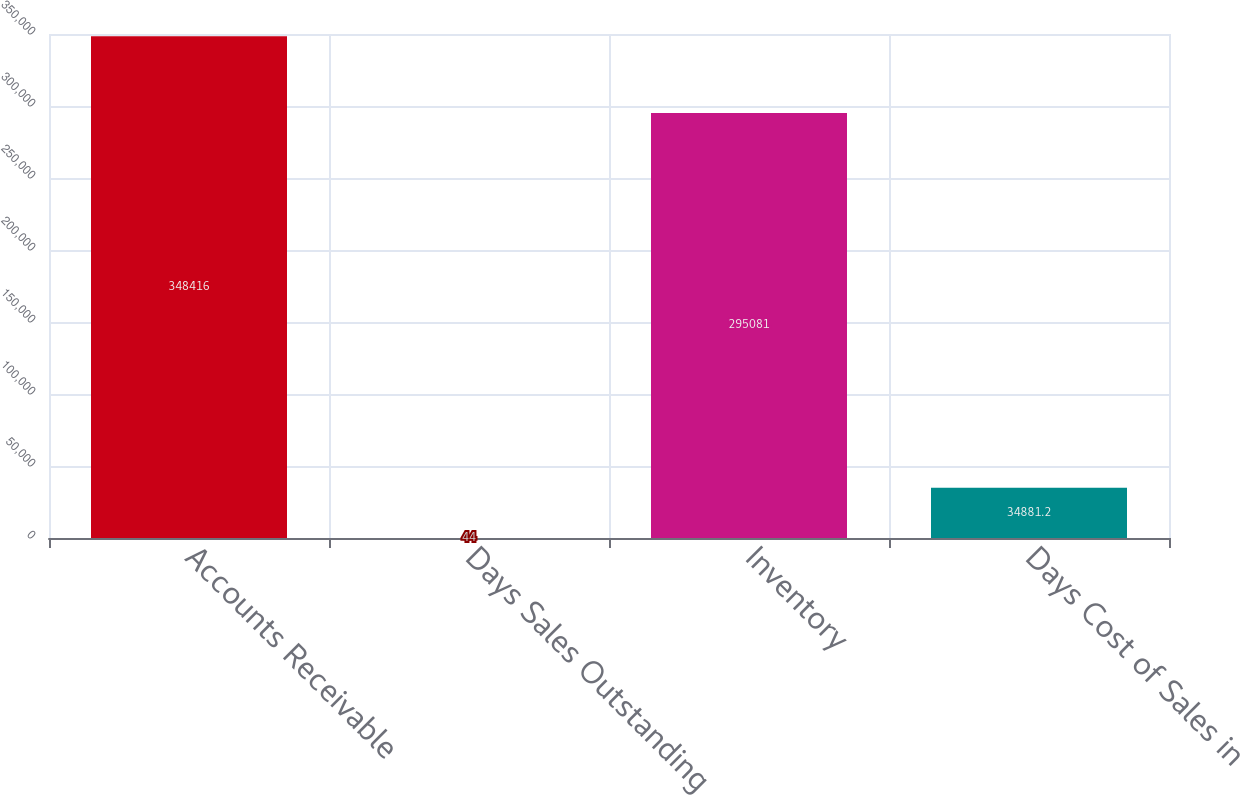Convert chart to OTSL. <chart><loc_0><loc_0><loc_500><loc_500><bar_chart><fcel>Accounts Receivable<fcel>Days Sales Outstanding<fcel>Inventory<fcel>Days Cost of Sales in<nl><fcel>348416<fcel>44<fcel>295081<fcel>34881.2<nl></chart> 